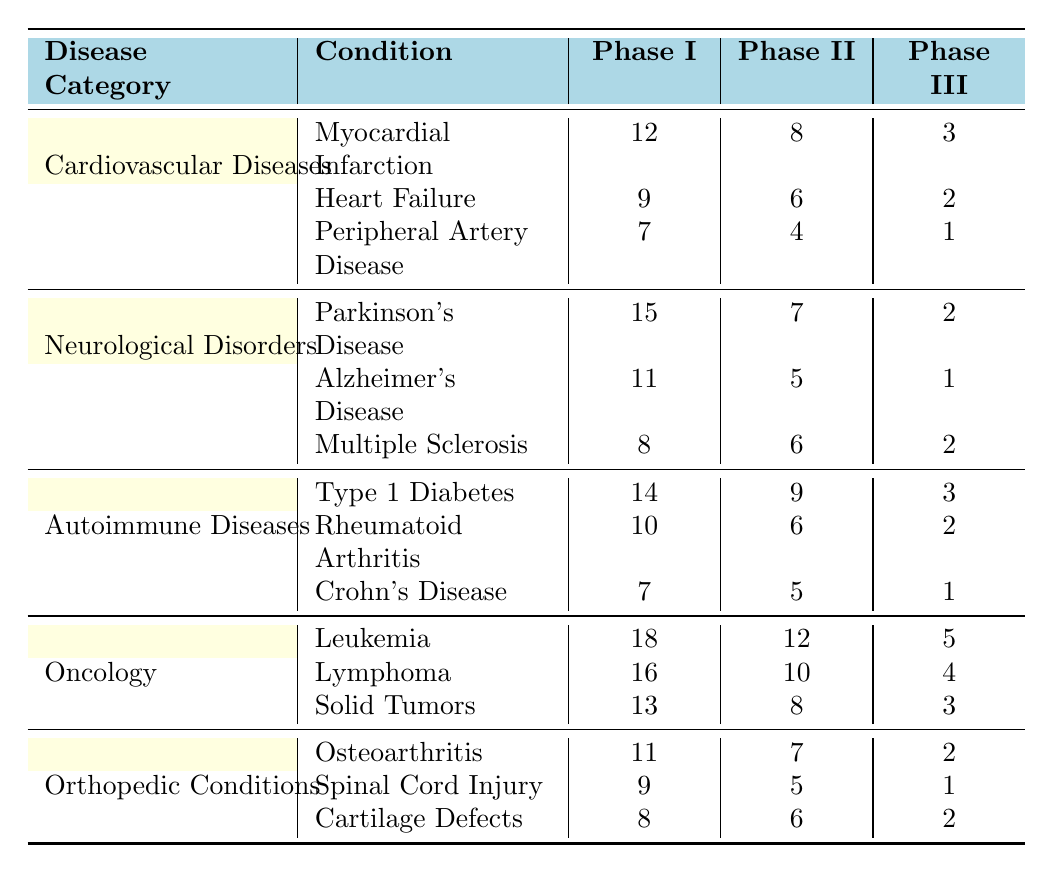What is the total number of Phase I clinical trials for Cardiovascular Diseases? To find the total number of Phase I trials for Cardiovascular Diseases, add the Phase I counts for each condition: Myocardial Infarction (12) + Heart Failure (9) + Peripheral Artery Disease (7) = 28.
Answer: 28 Which condition under Neurological Disorders has the highest number of Phase II trials? The Phase II counts for Neurological Disorders are Parkinson's Disease (7), Alzheimer's Disease (5), and Multiple Sclerosis (6). The highest is 7 for Parkinson's Disease.
Answer: Parkinson's Disease How many Phase III trials are there for Autoimmune Diseases in total? To calculate the total Phase III trials for Autoimmune Diseases, add: Type 1 Diabetes (3) + Rheumatoid Arthritis (2) + Crohn's Disease (1) = 6.
Answer: 6 Is there a condition under Oncology that has more Phase I trials than Solid Tumors? The Phase I counts for Oncology are: Leukemia (18), Lymphoma (16), and Solid Tumors (13). Both Leukemia and Lymphoma have more than Solid Tumors.
Answer: Yes What is the average number of Phase II trials across all conditions related to Orthopedic Conditions? The Phase II trials for Orthopedic Conditions are Osteoarthritis (7), Spinal Cord Injury (5), and Cartilage Defects (6). The total is 7 + 5 + 6 = 18. There are 3 conditions, so the average is 18/3 = 6.
Answer: 6 Which disease category has the highest sum of Phase III trials? First, sum the Phase III trials for each category: Cardiovascular Diseases (6), Neurological Disorders (5), Autoimmune Diseases (6), Oncology (12), and Orthopedic Conditions (5). The highest sum is for Oncology: 12.
Answer: Oncology What is the difference in the number of Phase I trials between the disease with the most and the least trials under Autoimmune Diseases? The Phase I counts for Autoimmune Diseases are: Type 1 Diabetes (14), Rheumatoid Arthritis (10), and Crohn's Disease (7). The highest is 14, and the lowest is 7, so the difference is 14 - 7 = 7.
Answer: 7 Which condition under Cardiovascular Diseases has the least number of Phase II trials? The Phase II trials for Cardiovascular Diseases are Myocardial Infarction (8), Heart Failure (6), and Peripheral Artery Disease (4). The least number is 4 for Peripheral Artery Disease.
Answer: Peripheral Artery Disease Are there more clinical trials for conditions under Oncology than under Orthopedic Conditions in Phase I? For Oncology, the Phase I trials are 18 + 16 + 13 = 47. For Orthopedic Conditions, they are 11 + 9 + 8 = 28. Since 47 > 28, there are more in Oncology.
Answer: Yes What is the total number of Phase I and Phase II trials for Neurological Disorders? For Neurological Disorders, the Phase I trials total 15 + 11 + 8 = 34 and Phase II total 7 + 5 + 6 = 18. The combined total is 34 + 18 = 52.
Answer: 52 